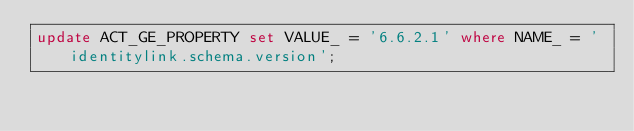Convert code to text. <code><loc_0><loc_0><loc_500><loc_500><_SQL_>update ACT_GE_PROPERTY set VALUE_ = '6.6.2.1' where NAME_ = 'identitylink.schema.version';
</code> 